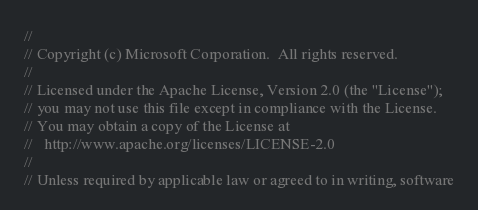<code> <loc_0><loc_0><loc_500><loc_500><_TypeScript_>//
// Copyright (c) Microsoft Corporation.  All rights reserved.
//
// Licensed under the Apache License, Version 2.0 (the "License");
// you may not use this file except in compliance with the License.
// You may obtain a copy of the License at
//   http://www.apache.org/licenses/LICENSE-2.0
//
// Unless required by applicable law or agreed to in writing, software</code> 